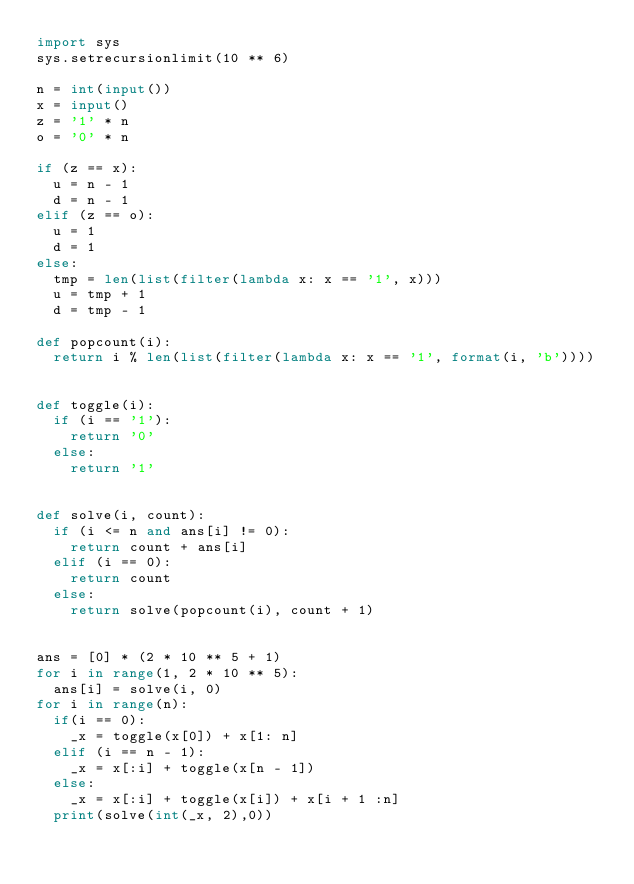<code> <loc_0><loc_0><loc_500><loc_500><_Python_>import sys
sys.setrecursionlimit(10 ** 6)

n = int(input())
x = input()
z = '1' * n
o = '0' * n

if (z == x):
  u = n - 1
  d = n - 1
elif (z == o):
  u = 1
  d = 1
else:
  tmp = len(list(filter(lambda x: x == '1', x)))
  u = tmp + 1
  d = tmp - 1

def popcount(i):
  return i % len(list(filter(lambda x: x == '1', format(i, 'b'))))


def toggle(i):
  if (i == '1'):
    return '0'
  else:
    return '1'


def solve(i, count):
  if (i <= n and ans[i] != 0):
    return count + ans[i]
  elif (i == 0):
    return count
  else:
    return solve(popcount(i), count + 1)


ans = [0] * (2 * 10 ** 5 + 1)
for i in range(1, 2 * 10 ** 5):
  ans[i] = solve(i, 0)
for i in range(n):
  if(i == 0):
    _x = toggle(x[0]) + x[1: n]
  elif (i == n - 1):
    _x = x[:i] + toggle(x[n - 1])
  else:
    _x = x[:i] + toggle(x[i]) + x[i + 1 :n]
  print(solve(int(_x, 2),0))
</code> 